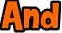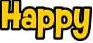Read the text from these images in sequence, separated by a semicolon. And; Happy 